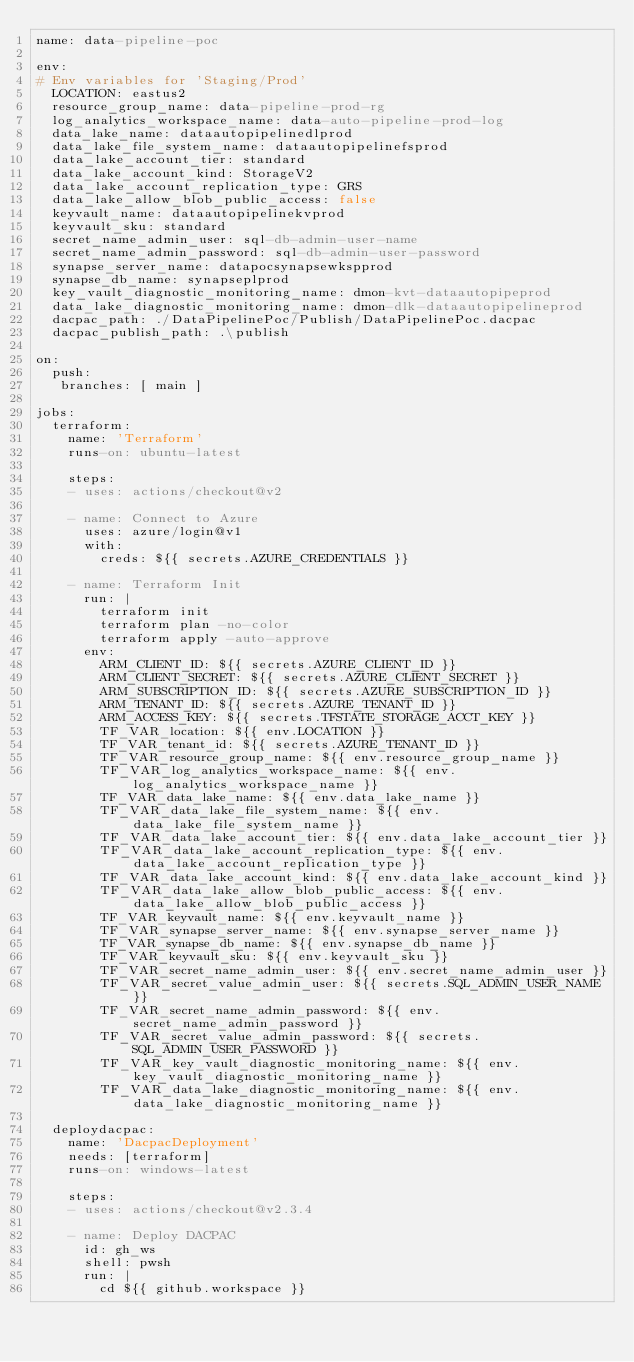<code> <loc_0><loc_0><loc_500><loc_500><_YAML_>name: data-pipeline-poc

env:
# Env variables for 'Staging/Prod'
  LOCATION: eastus2
  resource_group_name: data-pipeline-prod-rg
  log_analytics_workspace_name: data-auto-pipeline-prod-log
  data_lake_name: dataautopipelinedlprod
  data_lake_file_system_name: dataautopipelinefsprod
  data_lake_account_tier: standard
  data_lake_account_kind: StorageV2
  data_lake_account_replication_type: GRS
  data_lake_allow_blob_public_access: false
  keyvault_name: dataautopipelinekvprod
  keyvault_sku: standard
  secret_name_admin_user: sql-db-admin-user-name
  secret_name_admin_password: sql-db-admin-user-password
  synapse_server_name: datapocsynapsewkspprod
  synapse_db_name: synapseplprod
  key_vault_diagnostic_monitoring_name: dmon-kvt-dataautopipeprod
  data_lake_diagnostic_monitoring_name: dmon-dlk-dataautopipelineprod
  dacpac_path: ./DataPipelinePoc/Publish/DataPipelinePoc.dacpac
  dacpac_publish_path: .\publish

on:
  push:
   branches: [ main ]

jobs:
  terraform:
    name: 'Terraform'
    runs-on: ubuntu-latest

    steps:
    - uses: actions/checkout@v2

    - name: Connect to Azure
      uses: azure/login@v1
      with:
        creds: ${{ secrets.AZURE_CREDENTIALS }}
    
    - name: Terraform Init
      run: |
        terraform init
        terraform plan -no-color
        terraform apply -auto-approve
      env:
        ARM_CLIENT_ID: ${{ secrets.AZURE_CLIENT_ID }}
        ARM_CLIENT_SECRET: ${{ secrets.AZURE_CLIENT_SECRET }}
        ARM_SUBSCRIPTION_ID: ${{ secrets.AZURE_SUBSCRIPTION_ID }}
        ARM_TENANT_ID: ${{ secrets.AZURE_TENANT_ID }}
        ARM_ACCESS_KEY: ${{ secrets.TFSTATE_STORAGE_ACCT_KEY }}        
        TF_VAR_location: ${{ env.LOCATION }}
        TF_VAR_tenant_id: ${{ secrets.AZURE_TENANT_ID }}
        TF_VAR_resource_group_name: ${{ env.resource_group_name }}
        TF_VAR_log_analytics_workspace_name: ${{ env.log_analytics_workspace_name }}
        TF_VAR_data_lake_name: ${{ env.data_lake_name }}
        TF_VAR_data_lake_file_system_name: ${{ env.data_lake_file_system_name }}
        TF_VAR_data_lake_account_tier: ${{ env.data_lake_account_tier }}
        TF_VAR_data_lake_account_replication_type: ${{ env.data_lake_account_replication_type }}
        TF_VAR_data_lake_account_kind: ${{ env.data_lake_account_kind }}
        TF_VAR_data_lake_allow_blob_public_access: ${{ env.data_lake_allow_blob_public_access }}
        TF_VAR_keyvault_name: ${{ env.keyvault_name }}
        TF_VAR_synapse_server_name: ${{ env.synapse_server_name }}
        TF_VAR_synapse_db_name: ${{ env.synapse_db_name }}
        TF_VAR_keyvault_sku: ${{ env.keyvault_sku }}        
        TF_VAR_secret_name_admin_user: ${{ env.secret_name_admin_user }}
        TF_VAR_secret_value_admin_user: ${{ secrets.SQL_ADMIN_USER_NAME }}
        TF_VAR_secret_name_admin_password: ${{ env.secret_name_admin_password }}
        TF_VAR_secret_value_admin_password: ${{ secrets.SQL_ADMIN_USER_PASSWORD }}      
        TF_VAR_key_vault_diagnostic_monitoring_name: ${{ env.key_vault_diagnostic_monitoring_name }}
        TF_VAR_data_lake_diagnostic_monitoring_name: ${{ env.data_lake_diagnostic_monitoring_name }}
  
  deploydacpac:
    name: 'DacpacDeployment'
    needs: [terraform]
    runs-on: windows-latest

    steps:
    - uses: actions/checkout@v2.3.4

    - name: Deploy DACPAC
      id: gh_ws
      shell: pwsh
      run: |
        cd ${{ github.workspace }}</code> 